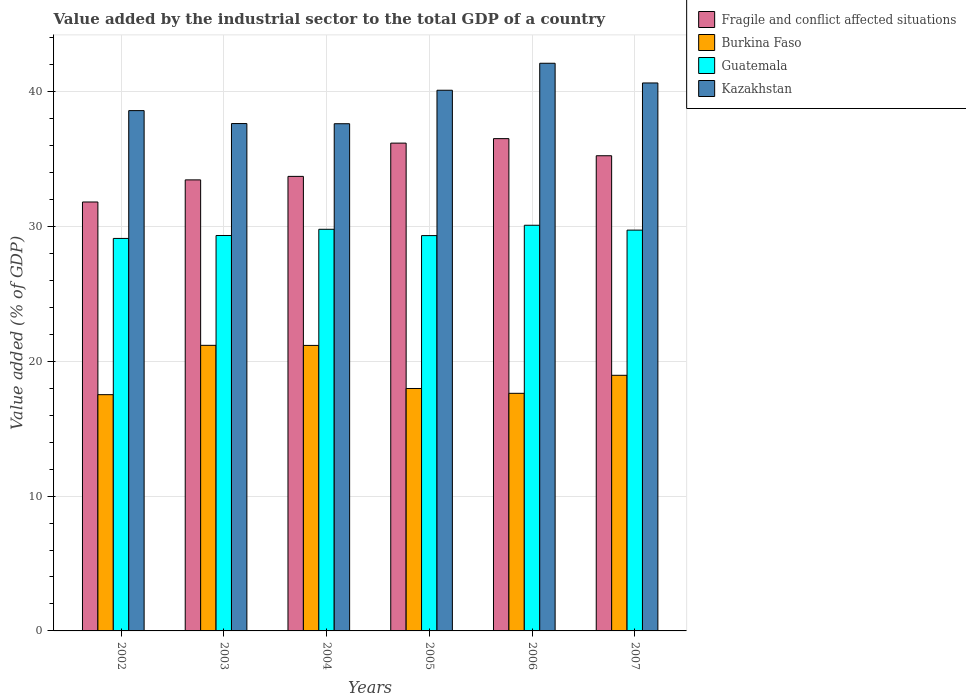How many different coloured bars are there?
Offer a terse response. 4. Are the number of bars per tick equal to the number of legend labels?
Your answer should be compact. Yes. Are the number of bars on each tick of the X-axis equal?
Provide a succinct answer. Yes. How many bars are there on the 6th tick from the right?
Provide a short and direct response. 4. What is the label of the 6th group of bars from the left?
Your answer should be very brief. 2007. In how many cases, is the number of bars for a given year not equal to the number of legend labels?
Ensure brevity in your answer.  0. What is the value added by the industrial sector to the total GDP in Kazakhstan in 2007?
Your answer should be very brief. 40.64. Across all years, what is the maximum value added by the industrial sector to the total GDP in Guatemala?
Keep it short and to the point. 30.09. Across all years, what is the minimum value added by the industrial sector to the total GDP in Kazakhstan?
Give a very brief answer. 37.62. In which year was the value added by the industrial sector to the total GDP in Fragile and conflict affected situations maximum?
Offer a very short reply. 2006. In which year was the value added by the industrial sector to the total GDP in Fragile and conflict affected situations minimum?
Ensure brevity in your answer.  2002. What is the total value added by the industrial sector to the total GDP in Fragile and conflict affected situations in the graph?
Ensure brevity in your answer.  206.91. What is the difference between the value added by the industrial sector to the total GDP in Burkina Faso in 2005 and that in 2006?
Offer a very short reply. 0.36. What is the difference between the value added by the industrial sector to the total GDP in Guatemala in 2007 and the value added by the industrial sector to the total GDP in Burkina Faso in 2002?
Provide a short and direct response. 12.2. What is the average value added by the industrial sector to the total GDP in Burkina Faso per year?
Keep it short and to the point. 19.07. In the year 2004, what is the difference between the value added by the industrial sector to the total GDP in Fragile and conflict affected situations and value added by the industrial sector to the total GDP in Kazakhstan?
Your response must be concise. -3.9. In how many years, is the value added by the industrial sector to the total GDP in Fragile and conflict affected situations greater than 22 %?
Keep it short and to the point. 6. What is the ratio of the value added by the industrial sector to the total GDP in Fragile and conflict affected situations in 2004 to that in 2006?
Your response must be concise. 0.92. Is the value added by the industrial sector to the total GDP in Kazakhstan in 2002 less than that in 2005?
Your answer should be very brief. Yes. What is the difference between the highest and the second highest value added by the industrial sector to the total GDP in Kazakhstan?
Provide a succinct answer. 1.46. What is the difference between the highest and the lowest value added by the industrial sector to the total GDP in Guatemala?
Your response must be concise. 0.98. Is it the case that in every year, the sum of the value added by the industrial sector to the total GDP in Guatemala and value added by the industrial sector to the total GDP in Kazakhstan is greater than the sum of value added by the industrial sector to the total GDP in Fragile and conflict affected situations and value added by the industrial sector to the total GDP in Burkina Faso?
Keep it short and to the point. No. What does the 1st bar from the left in 2006 represents?
Provide a short and direct response. Fragile and conflict affected situations. What does the 3rd bar from the right in 2004 represents?
Offer a terse response. Burkina Faso. Is it the case that in every year, the sum of the value added by the industrial sector to the total GDP in Burkina Faso and value added by the industrial sector to the total GDP in Kazakhstan is greater than the value added by the industrial sector to the total GDP in Guatemala?
Provide a short and direct response. Yes. Are all the bars in the graph horizontal?
Your answer should be compact. No. How many years are there in the graph?
Your answer should be compact. 6. Are the values on the major ticks of Y-axis written in scientific E-notation?
Your answer should be very brief. No. Does the graph contain grids?
Your response must be concise. Yes. How many legend labels are there?
Your answer should be very brief. 4. What is the title of the graph?
Offer a very short reply. Value added by the industrial sector to the total GDP of a country. What is the label or title of the Y-axis?
Keep it short and to the point. Value added (% of GDP). What is the Value added (% of GDP) in Fragile and conflict affected situations in 2002?
Your answer should be very brief. 31.81. What is the Value added (% of GDP) in Burkina Faso in 2002?
Give a very brief answer. 17.52. What is the Value added (% of GDP) of Guatemala in 2002?
Keep it short and to the point. 29.11. What is the Value added (% of GDP) in Kazakhstan in 2002?
Offer a very short reply. 38.59. What is the Value added (% of GDP) in Fragile and conflict affected situations in 2003?
Provide a short and direct response. 33.45. What is the Value added (% of GDP) in Burkina Faso in 2003?
Provide a succinct answer. 21.18. What is the Value added (% of GDP) of Guatemala in 2003?
Provide a short and direct response. 29.33. What is the Value added (% of GDP) in Kazakhstan in 2003?
Offer a terse response. 37.63. What is the Value added (% of GDP) in Fragile and conflict affected situations in 2004?
Keep it short and to the point. 33.71. What is the Value added (% of GDP) in Burkina Faso in 2004?
Your answer should be very brief. 21.18. What is the Value added (% of GDP) in Guatemala in 2004?
Your answer should be very brief. 29.79. What is the Value added (% of GDP) in Kazakhstan in 2004?
Give a very brief answer. 37.62. What is the Value added (% of GDP) in Fragile and conflict affected situations in 2005?
Ensure brevity in your answer.  36.18. What is the Value added (% of GDP) in Burkina Faso in 2005?
Give a very brief answer. 17.98. What is the Value added (% of GDP) in Guatemala in 2005?
Your answer should be very brief. 29.32. What is the Value added (% of GDP) of Kazakhstan in 2005?
Ensure brevity in your answer.  40.1. What is the Value added (% of GDP) of Fragile and conflict affected situations in 2006?
Your response must be concise. 36.51. What is the Value added (% of GDP) in Burkina Faso in 2006?
Offer a very short reply. 17.62. What is the Value added (% of GDP) of Guatemala in 2006?
Your answer should be very brief. 30.09. What is the Value added (% of GDP) of Kazakhstan in 2006?
Provide a succinct answer. 42.1. What is the Value added (% of GDP) of Fragile and conflict affected situations in 2007?
Keep it short and to the point. 35.24. What is the Value added (% of GDP) in Burkina Faso in 2007?
Keep it short and to the point. 18.96. What is the Value added (% of GDP) of Guatemala in 2007?
Provide a short and direct response. 29.73. What is the Value added (% of GDP) in Kazakhstan in 2007?
Ensure brevity in your answer.  40.64. Across all years, what is the maximum Value added (% of GDP) in Fragile and conflict affected situations?
Your answer should be compact. 36.51. Across all years, what is the maximum Value added (% of GDP) in Burkina Faso?
Keep it short and to the point. 21.18. Across all years, what is the maximum Value added (% of GDP) in Guatemala?
Make the answer very short. 30.09. Across all years, what is the maximum Value added (% of GDP) of Kazakhstan?
Offer a terse response. 42.1. Across all years, what is the minimum Value added (% of GDP) of Fragile and conflict affected situations?
Offer a very short reply. 31.81. Across all years, what is the minimum Value added (% of GDP) of Burkina Faso?
Make the answer very short. 17.52. Across all years, what is the minimum Value added (% of GDP) in Guatemala?
Offer a very short reply. 29.11. Across all years, what is the minimum Value added (% of GDP) in Kazakhstan?
Your answer should be very brief. 37.62. What is the total Value added (% of GDP) of Fragile and conflict affected situations in the graph?
Keep it short and to the point. 206.91. What is the total Value added (% of GDP) in Burkina Faso in the graph?
Give a very brief answer. 114.44. What is the total Value added (% of GDP) of Guatemala in the graph?
Offer a terse response. 177.36. What is the total Value added (% of GDP) of Kazakhstan in the graph?
Offer a very short reply. 236.67. What is the difference between the Value added (% of GDP) of Fragile and conflict affected situations in 2002 and that in 2003?
Keep it short and to the point. -1.64. What is the difference between the Value added (% of GDP) in Burkina Faso in 2002 and that in 2003?
Provide a succinct answer. -3.66. What is the difference between the Value added (% of GDP) of Guatemala in 2002 and that in 2003?
Your answer should be compact. -0.22. What is the difference between the Value added (% of GDP) of Kazakhstan in 2002 and that in 2003?
Your answer should be compact. 0.96. What is the difference between the Value added (% of GDP) in Fragile and conflict affected situations in 2002 and that in 2004?
Offer a terse response. -1.9. What is the difference between the Value added (% of GDP) of Burkina Faso in 2002 and that in 2004?
Make the answer very short. -3.65. What is the difference between the Value added (% of GDP) of Guatemala in 2002 and that in 2004?
Provide a short and direct response. -0.68. What is the difference between the Value added (% of GDP) in Kazakhstan in 2002 and that in 2004?
Offer a very short reply. 0.97. What is the difference between the Value added (% of GDP) of Fragile and conflict affected situations in 2002 and that in 2005?
Keep it short and to the point. -4.37. What is the difference between the Value added (% of GDP) in Burkina Faso in 2002 and that in 2005?
Make the answer very short. -0.46. What is the difference between the Value added (% of GDP) of Guatemala in 2002 and that in 2005?
Offer a very short reply. -0.21. What is the difference between the Value added (% of GDP) of Kazakhstan in 2002 and that in 2005?
Give a very brief answer. -1.51. What is the difference between the Value added (% of GDP) in Fragile and conflict affected situations in 2002 and that in 2006?
Keep it short and to the point. -4.7. What is the difference between the Value added (% of GDP) in Burkina Faso in 2002 and that in 2006?
Provide a succinct answer. -0.1. What is the difference between the Value added (% of GDP) in Guatemala in 2002 and that in 2006?
Keep it short and to the point. -0.98. What is the difference between the Value added (% of GDP) in Kazakhstan in 2002 and that in 2006?
Make the answer very short. -3.51. What is the difference between the Value added (% of GDP) in Fragile and conflict affected situations in 2002 and that in 2007?
Keep it short and to the point. -3.43. What is the difference between the Value added (% of GDP) in Burkina Faso in 2002 and that in 2007?
Make the answer very short. -1.44. What is the difference between the Value added (% of GDP) of Guatemala in 2002 and that in 2007?
Your answer should be compact. -0.62. What is the difference between the Value added (% of GDP) in Kazakhstan in 2002 and that in 2007?
Keep it short and to the point. -2.05. What is the difference between the Value added (% of GDP) in Fragile and conflict affected situations in 2003 and that in 2004?
Provide a succinct answer. -0.26. What is the difference between the Value added (% of GDP) in Burkina Faso in 2003 and that in 2004?
Provide a short and direct response. 0.01. What is the difference between the Value added (% of GDP) of Guatemala in 2003 and that in 2004?
Your answer should be compact. -0.46. What is the difference between the Value added (% of GDP) of Kazakhstan in 2003 and that in 2004?
Keep it short and to the point. 0.01. What is the difference between the Value added (% of GDP) in Fragile and conflict affected situations in 2003 and that in 2005?
Your response must be concise. -2.73. What is the difference between the Value added (% of GDP) of Burkina Faso in 2003 and that in 2005?
Provide a short and direct response. 3.2. What is the difference between the Value added (% of GDP) of Guatemala in 2003 and that in 2005?
Give a very brief answer. 0.01. What is the difference between the Value added (% of GDP) in Kazakhstan in 2003 and that in 2005?
Your response must be concise. -2.47. What is the difference between the Value added (% of GDP) of Fragile and conflict affected situations in 2003 and that in 2006?
Provide a short and direct response. -3.06. What is the difference between the Value added (% of GDP) in Burkina Faso in 2003 and that in 2006?
Your response must be concise. 3.56. What is the difference between the Value added (% of GDP) in Guatemala in 2003 and that in 2006?
Offer a terse response. -0.76. What is the difference between the Value added (% of GDP) in Kazakhstan in 2003 and that in 2006?
Make the answer very short. -4.47. What is the difference between the Value added (% of GDP) of Fragile and conflict affected situations in 2003 and that in 2007?
Give a very brief answer. -1.79. What is the difference between the Value added (% of GDP) in Burkina Faso in 2003 and that in 2007?
Ensure brevity in your answer.  2.22. What is the difference between the Value added (% of GDP) of Guatemala in 2003 and that in 2007?
Your answer should be compact. -0.4. What is the difference between the Value added (% of GDP) in Kazakhstan in 2003 and that in 2007?
Provide a succinct answer. -3.01. What is the difference between the Value added (% of GDP) in Fragile and conflict affected situations in 2004 and that in 2005?
Provide a succinct answer. -2.47. What is the difference between the Value added (% of GDP) of Burkina Faso in 2004 and that in 2005?
Make the answer very short. 3.2. What is the difference between the Value added (% of GDP) of Guatemala in 2004 and that in 2005?
Give a very brief answer. 0.47. What is the difference between the Value added (% of GDP) of Kazakhstan in 2004 and that in 2005?
Your response must be concise. -2.48. What is the difference between the Value added (% of GDP) in Fragile and conflict affected situations in 2004 and that in 2006?
Your response must be concise. -2.8. What is the difference between the Value added (% of GDP) in Burkina Faso in 2004 and that in 2006?
Ensure brevity in your answer.  3.55. What is the difference between the Value added (% of GDP) in Guatemala in 2004 and that in 2006?
Your response must be concise. -0.3. What is the difference between the Value added (% of GDP) in Kazakhstan in 2004 and that in 2006?
Your answer should be compact. -4.49. What is the difference between the Value added (% of GDP) in Fragile and conflict affected situations in 2004 and that in 2007?
Offer a very short reply. -1.53. What is the difference between the Value added (% of GDP) in Burkina Faso in 2004 and that in 2007?
Provide a short and direct response. 2.22. What is the difference between the Value added (% of GDP) in Guatemala in 2004 and that in 2007?
Give a very brief answer. 0.06. What is the difference between the Value added (% of GDP) of Kazakhstan in 2004 and that in 2007?
Give a very brief answer. -3.02. What is the difference between the Value added (% of GDP) of Fragile and conflict affected situations in 2005 and that in 2006?
Offer a very short reply. -0.33. What is the difference between the Value added (% of GDP) of Burkina Faso in 2005 and that in 2006?
Your answer should be very brief. 0.36. What is the difference between the Value added (% of GDP) in Guatemala in 2005 and that in 2006?
Your response must be concise. -0.77. What is the difference between the Value added (% of GDP) of Kazakhstan in 2005 and that in 2006?
Your response must be concise. -2. What is the difference between the Value added (% of GDP) of Fragile and conflict affected situations in 2005 and that in 2007?
Offer a very short reply. 0.94. What is the difference between the Value added (% of GDP) of Burkina Faso in 2005 and that in 2007?
Your answer should be compact. -0.98. What is the difference between the Value added (% of GDP) of Guatemala in 2005 and that in 2007?
Provide a short and direct response. -0.41. What is the difference between the Value added (% of GDP) of Kazakhstan in 2005 and that in 2007?
Provide a short and direct response. -0.54. What is the difference between the Value added (% of GDP) of Fragile and conflict affected situations in 2006 and that in 2007?
Your response must be concise. 1.27. What is the difference between the Value added (% of GDP) in Burkina Faso in 2006 and that in 2007?
Ensure brevity in your answer.  -1.34. What is the difference between the Value added (% of GDP) of Guatemala in 2006 and that in 2007?
Give a very brief answer. 0.36. What is the difference between the Value added (% of GDP) in Kazakhstan in 2006 and that in 2007?
Ensure brevity in your answer.  1.46. What is the difference between the Value added (% of GDP) in Fragile and conflict affected situations in 2002 and the Value added (% of GDP) in Burkina Faso in 2003?
Make the answer very short. 10.63. What is the difference between the Value added (% of GDP) in Fragile and conflict affected situations in 2002 and the Value added (% of GDP) in Guatemala in 2003?
Make the answer very short. 2.48. What is the difference between the Value added (% of GDP) of Fragile and conflict affected situations in 2002 and the Value added (% of GDP) of Kazakhstan in 2003?
Make the answer very short. -5.82. What is the difference between the Value added (% of GDP) of Burkina Faso in 2002 and the Value added (% of GDP) of Guatemala in 2003?
Make the answer very short. -11.8. What is the difference between the Value added (% of GDP) in Burkina Faso in 2002 and the Value added (% of GDP) in Kazakhstan in 2003?
Provide a succinct answer. -20.11. What is the difference between the Value added (% of GDP) in Guatemala in 2002 and the Value added (% of GDP) in Kazakhstan in 2003?
Your answer should be compact. -8.52. What is the difference between the Value added (% of GDP) of Fragile and conflict affected situations in 2002 and the Value added (% of GDP) of Burkina Faso in 2004?
Offer a terse response. 10.64. What is the difference between the Value added (% of GDP) in Fragile and conflict affected situations in 2002 and the Value added (% of GDP) in Guatemala in 2004?
Offer a terse response. 2.02. What is the difference between the Value added (% of GDP) in Fragile and conflict affected situations in 2002 and the Value added (% of GDP) in Kazakhstan in 2004?
Your response must be concise. -5.8. What is the difference between the Value added (% of GDP) of Burkina Faso in 2002 and the Value added (% of GDP) of Guatemala in 2004?
Offer a terse response. -12.27. What is the difference between the Value added (% of GDP) in Burkina Faso in 2002 and the Value added (% of GDP) in Kazakhstan in 2004?
Ensure brevity in your answer.  -20.09. What is the difference between the Value added (% of GDP) in Guatemala in 2002 and the Value added (% of GDP) in Kazakhstan in 2004?
Offer a very short reply. -8.51. What is the difference between the Value added (% of GDP) in Fragile and conflict affected situations in 2002 and the Value added (% of GDP) in Burkina Faso in 2005?
Provide a short and direct response. 13.83. What is the difference between the Value added (% of GDP) in Fragile and conflict affected situations in 2002 and the Value added (% of GDP) in Guatemala in 2005?
Your answer should be compact. 2.49. What is the difference between the Value added (% of GDP) of Fragile and conflict affected situations in 2002 and the Value added (% of GDP) of Kazakhstan in 2005?
Ensure brevity in your answer.  -8.29. What is the difference between the Value added (% of GDP) in Burkina Faso in 2002 and the Value added (% of GDP) in Guatemala in 2005?
Your answer should be compact. -11.8. What is the difference between the Value added (% of GDP) in Burkina Faso in 2002 and the Value added (% of GDP) in Kazakhstan in 2005?
Your answer should be compact. -22.58. What is the difference between the Value added (% of GDP) in Guatemala in 2002 and the Value added (% of GDP) in Kazakhstan in 2005?
Your response must be concise. -10.99. What is the difference between the Value added (% of GDP) of Fragile and conflict affected situations in 2002 and the Value added (% of GDP) of Burkina Faso in 2006?
Provide a short and direct response. 14.19. What is the difference between the Value added (% of GDP) of Fragile and conflict affected situations in 2002 and the Value added (% of GDP) of Guatemala in 2006?
Provide a short and direct response. 1.72. What is the difference between the Value added (% of GDP) in Fragile and conflict affected situations in 2002 and the Value added (% of GDP) in Kazakhstan in 2006?
Your answer should be compact. -10.29. What is the difference between the Value added (% of GDP) of Burkina Faso in 2002 and the Value added (% of GDP) of Guatemala in 2006?
Provide a short and direct response. -12.56. What is the difference between the Value added (% of GDP) in Burkina Faso in 2002 and the Value added (% of GDP) in Kazakhstan in 2006?
Your answer should be very brief. -24.58. What is the difference between the Value added (% of GDP) in Guatemala in 2002 and the Value added (% of GDP) in Kazakhstan in 2006?
Keep it short and to the point. -12.99. What is the difference between the Value added (% of GDP) in Fragile and conflict affected situations in 2002 and the Value added (% of GDP) in Burkina Faso in 2007?
Make the answer very short. 12.85. What is the difference between the Value added (% of GDP) in Fragile and conflict affected situations in 2002 and the Value added (% of GDP) in Guatemala in 2007?
Offer a terse response. 2.09. What is the difference between the Value added (% of GDP) of Fragile and conflict affected situations in 2002 and the Value added (% of GDP) of Kazakhstan in 2007?
Offer a terse response. -8.83. What is the difference between the Value added (% of GDP) of Burkina Faso in 2002 and the Value added (% of GDP) of Guatemala in 2007?
Offer a very short reply. -12.2. What is the difference between the Value added (% of GDP) in Burkina Faso in 2002 and the Value added (% of GDP) in Kazakhstan in 2007?
Make the answer very short. -23.12. What is the difference between the Value added (% of GDP) of Guatemala in 2002 and the Value added (% of GDP) of Kazakhstan in 2007?
Give a very brief answer. -11.53. What is the difference between the Value added (% of GDP) in Fragile and conflict affected situations in 2003 and the Value added (% of GDP) in Burkina Faso in 2004?
Your answer should be compact. 12.28. What is the difference between the Value added (% of GDP) of Fragile and conflict affected situations in 2003 and the Value added (% of GDP) of Guatemala in 2004?
Keep it short and to the point. 3.66. What is the difference between the Value added (% of GDP) in Fragile and conflict affected situations in 2003 and the Value added (% of GDP) in Kazakhstan in 2004?
Your response must be concise. -4.16. What is the difference between the Value added (% of GDP) in Burkina Faso in 2003 and the Value added (% of GDP) in Guatemala in 2004?
Provide a short and direct response. -8.61. What is the difference between the Value added (% of GDP) in Burkina Faso in 2003 and the Value added (% of GDP) in Kazakhstan in 2004?
Make the answer very short. -16.44. What is the difference between the Value added (% of GDP) in Guatemala in 2003 and the Value added (% of GDP) in Kazakhstan in 2004?
Make the answer very short. -8.29. What is the difference between the Value added (% of GDP) of Fragile and conflict affected situations in 2003 and the Value added (% of GDP) of Burkina Faso in 2005?
Your answer should be very brief. 15.47. What is the difference between the Value added (% of GDP) in Fragile and conflict affected situations in 2003 and the Value added (% of GDP) in Guatemala in 2005?
Provide a succinct answer. 4.13. What is the difference between the Value added (% of GDP) in Fragile and conflict affected situations in 2003 and the Value added (% of GDP) in Kazakhstan in 2005?
Offer a very short reply. -6.65. What is the difference between the Value added (% of GDP) of Burkina Faso in 2003 and the Value added (% of GDP) of Guatemala in 2005?
Provide a succinct answer. -8.14. What is the difference between the Value added (% of GDP) in Burkina Faso in 2003 and the Value added (% of GDP) in Kazakhstan in 2005?
Offer a very short reply. -18.92. What is the difference between the Value added (% of GDP) in Guatemala in 2003 and the Value added (% of GDP) in Kazakhstan in 2005?
Offer a very short reply. -10.77. What is the difference between the Value added (% of GDP) of Fragile and conflict affected situations in 2003 and the Value added (% of GDP) of Burkina Faso in 2006?
Provide a short and direct response. 15.83. What is the difference between the Value added (% of GDP) of Fragile and conflict affected situations in 2003 and the Value added (% of GDP) of Guatemala in 2006?
Your answer should be compact. 3.37. What is the difference between the Value added (% of GDP) in Fragile and conflict affected situations in 2003 and the Value added (% of GDP) in Kazakhstan in 2006?
Offer a terse response. -8.65. What is the difference between the Value added (% of GDP) of Burkina Faso in 2003 and the Value added (% of GDP) of Guatemala in 2006?
Keep it short and to the point. -8.91. What is the difference between the Value added (% of GDP) of Burkina Faso in 2003 and the Value added (% of GDP) of Kazakhstan in 2006?
Ensure brevity in your answer.  -20.92. What is the difference between the Value added (% of GDP) in Guatemala in 2003 and the Value added (% of GDP) in Kazakhstan in 2006?
Provide a short and direct response. -12.77. What is the difference between the Value added (% of GDP) in Fragile and conflict affected situations in 2003 and the Value added (% of GDP) in Burkina Faso in 2007?
Offer a very short reply. 14.49. What is the difference between the Value added (% of GDP) of Fragile and conflict affected situations in 2003 and the Value added (% of GDP) of Guatemala in 2007?
Keep it short and to the point. 3.73. What is the difference between the Value added (% of GDP) in Fragile and conflict affected situations in 2003 and the Value added (% of GDP) in Kazakhstan in 2007?
Provide a succinct answer. -7.19. What is the difference between the Value added (% of GDP) of Burkina Faso in 2003 and the Value added (% of GDP) of Guatemala in 2007?
Offer a terse response. -8.54. What is the difference between the Value added (% of GDP) of Burkina Faso in 2003 and the Value added (% of GDP) of Kazakhstan in 2007?
Keep it short and to the point. -19.46. What is the difference between the Value added (% of GDP) in Guatemala in 2003 and the Value added (% of GDP) in Kazakhstan in 2007?
Your response must be concise. -11.31. What is the difference between the Value added (% of GDP) in Fragile and conflict affected situations in 2004 and the Value added (% of GDP) in Burkina Faso in 2005?
Ensure brevity in your answer.  15.73. What is the difference between the Value added (% of GDP) in Fragile and conflict affected situations in 2004 and the Value added (% of GDP) in Guatemala in 2005?
Provide a succinct answer. 4.39. What is the difference between the Value added (% of GDP) in Fragile and conflict affected situations in 2004 and the Value added (% of GDP) in Kazakhstan in 2005?
Provide a succinct answer. -6.39. What is the difference between the Value added (% of GDP) in Burkina Faso in 2004 and the Value added (% of GDP) in Guatemala in 2005?
Give a very brief answer. -8.14. What is the difference between the Value added (% of GDP) in Burkina Faso in 2004 and the Value added (% of GDP) in Kazakhstan in 2005?
Your answer should be very brief. -18.92. What is the difference between the Value added (% of GDP) in Guatemala in 2004 and the Value added (% of GDP) in Kazakhstan in 2005?
Provide a short and direct response. -10.31. What is the difference between the Value added (% of GDP) of Fragile and conflict affected situations in 2004 and the Value added (% of GDP) of Burkina Faso in 2006?
Offer a very short reply. 16.09. What is the difference between the Value added (% of GDP) of Fragile and conflict affected situations in 2004 and the Value added (% of GDP) of Guatemala in 2006?
Your answer should be very brief. 3.62. What is the difference between the Value added (% of GDP) of Fragile and conflict affected situations in 2004 and the Value added (% of GDP) of Kazakhstan in 2006?
Offer a terse response. -8.39. What is the difference between the Value added (% of GDP) of Burkina Faso in 2004 and the Value added (% of GDP) of Guatemala in 2006?
Your answer should be very brief. -8.91. What is the difference between the Value added (% of GDP) in Burkina Faso in 2004 and the Value added (% of GDP) in Kazakhstan in 2006?
Your answer should be compact. -20.93. What is the difference between the Value added (% of GDP) in Guatemala in 2004 and the Value added (% of GDP) in Kazakhstan in 2006?
Make the answer very short. -12.31. What is the difference between the Value added (% of GDP) of Fragile and conflict affected situations in 2004 and the Value added (% of GDP) of Burkina Faso in 2007?
Your answer should be very brief. 14.75. What is the difference between the Value added (% of GDP) of Fragile and conflict affected situations in 2004 and the Value added (% of GDP) of Guatemala in 2007?
Provide a short and direct response. 3.99. What is the difference between the Value added (% of GDP) in Fragile and conflict affected situations in 2004 and the Value added (% of GDP) in Kazakhstan in 2007?
Make the answer very short. -6.93. What is the difference between the Value added (% of GDP) of Burkina Faso in 2004 and the Value added (% of GDP) of Guatemala in 2007?
Ensure brevity in your answer.  -8.55. What is the difference between the Value added (% of GDP) in Burkina Faso in 2004 and the Value added (% of GDP) in Kazakhstan in 2007?
Provide a short and direct response. -19.46. What is the difference between the Value added (% of GDP) in Guatemala in 2004 and the Value added (% of GDP) in Kazakhstan in 2007?
Ensure brevity in your answer.  -10.85. What is the difference between the Value added (% of GDP) in Fragile and conflict affected situations in 2005 and the Value added (% of GDP) in Burkina Faso in 2006?
Offer a terse response. 18.56. What is the difference between the Value added (% of GDP) in Fragile and conflict affected situations in 2005 and the Value added (% of GDP) in Guatemala in 2006?
Offer a very short reply. 6.09. What is the difference between the Value added (% of GDP) of Fragile and conflict affected situations in 2005 and the Value added (% of GDP) of Kazakhstan in 2006?
Offer a terse response. -5.92. What is the difference between the Value added (% of GDP) of Burkina Faso in 2005 and the Value added (% of GDP) of Guatemala in 2006?
Offer a terse response. -12.11. What is the difference between the Value added (% of GDP) in Burkina Faso in 2005 and the Value added (% of GDP) in Kazakhstan in 2006?
Make the answer very short. -24.12. What is the difference between the Value added (% of GDP) in Guatemala in 2005 and the Value added (% of GDP) in Kazakhstan in 2006?
Provide a short and direct response. -12.78. What is the difference between the Value added (% of GDP) of Fragile and conflict affected situations in 2005 and the Value added (% of GDP) of Burkina Faso in 2007?
Your answer should be very brief. 17.22. What is the difference between the Value added (% of GDP) in Fragile and conflict affected situations in 2005 and the Value added (% of GDP) in Guatemala in 2007?
Offer a terse response. 6.45. What is the difference between the Value added (% of GDP) in Fragile and conflict affected situations in 2005 and the Value added (% of GDP) in Kazakhstan in 2007?
Provide a short and direct response. -4.46. What is the difference between the Value added (% of GDP) in Burkina Faso in 2005 and the Value added (% of GDP) in Guatemala in 2007?
Keep it short and to the point. -11.75. What is the difference between the Value added (% of GDP) in Burkina Faso in 2005 and the Value added (% of GDP) in Kazakhstan in 2007?
Provide a succinct answer. -22.66. What is the difference between the Value added (% of GDP) in Guatemala in 2005 and the Value added (% of GDP) in Kazakhstan in 2007?
Your answer should be very brief. -11.32. What is the difference between the Value added (% of GDP) of Fragile and conflict affected situations in 2006 and the Value added (% of GDP) of Burkina Faso in 2007?
Your response must be concise. 17.55. What is the difference between the Value added (% of GDP) of Fragile and conflict affected situations in 2006 and the Value added (% of GDP) of Guatemala in 2007?
Provide a short and direct response. 6.78. What is the difference between the Value added (% of GDP) of Fragile and conflict affected situations in 2006 and the Value added (% of GDP) of Kazakhstan in 2007?
Give a very brief answer. -4.13. What is the difference between the Value added (% of GDP) of Burkina Faso in 2006 and the Value added (% of GDP) of Guatemala in 2007?
Offer a very short reply. -12.1. What is the difference between the Value added (% of GDP) in Burkina Faso in 2006 and the Value added (% of GDP) in Kazakhstan in 2007?
Make the answer very short. -23.02. What is the difference between the Value added (% of GDP) in Guatemala in 2006 and the Value added (% of GDP) in Kazakhstan in 2007?
Make the answer very short. -10.55. What is the average Value added (% of GDP) of Fragile and conflict affected situations per year?
Give a very brief answer. 34.48. What is the average Value added (% of GDP) in Burkina Faso per year?
Make the answer very short. 19.07. What is the average Value added (% of GDP) in Guatemala per year?
Make the answer very short. 29.56. What is the average Value added (% of GDP) in Kazakhstan per year?
Offer a terse response. 39.45. In the year 2002, what is the difference between the Value added (% of GDP) of Fragile and conflict affected situations and Value added (% of GDP) of Burkina Faso?
Your answer should be very brief. 14.29. In the year 2002, what is the difference between the Value added (% of GDP) of Fragile and conflict affected situations and Value added (% of GDP) of Guatemala?
Keep it short and to the point. 2.7. In the year 2002, what is the difference between the Value added (% of GDP) in Fragile and conflict affected situations and Value added (% of GDP) in Kazakhstan?
Give a very brief answer. -6.78. In the year 2002, what is the difference between the Value added (% of GDP) in Burkina Faso and Value added (% of GDP) in Guatemala?
Provide a short and direct response. -11.59. In the year 2002, what is the difference between the Value added (% of GDP) of Burkina Faso and Value added (% of GDP) of Kazakhstan?
Make the answer very short. -21.07. In the year 2002, what is the difference between the Value added (% of GDP) in Guatemala and Value added (% of GDP) in Kazakhstan?
Provide a short and direct response. -9.48. In the year 2003, what is the difference between the Value added (% of GDP) of Fragile and conflict affected situations and Value added (% of GDP) of Burkina Faso?
Ensure brevity in your answer.  12.27. In the year 2003, what is the difference between the Value added (% of GDP) of Fragile and conflict affected situations and Value added (% of GDP) of Guatemala?
Your answer should be compact. 4.13. In the year 2003, what is the difference between the Value added (% of GDP) in Fragile and conflict affected situations and Value added (% of GDP) in Kazakhstan?
Offer a terse response. -4.18. In the year 2003, what is the difference between the Value added (% of GDP) in Burkina Faso and Value added (% of GDP) in Guatemala?
Your answer should be compact. -8.15. In the year 2003, what is the difference between the Value added (% of GDP) in Burkina Faso and Value added (% of GDP) in Kazakhstan?
Your response must be concise. -16.45. In the year 2003, what is the difference between the Value added (% of GDP) in Guatemala and Value added (% of GDP) in Kazakhstan?
Your response must be concise. -8.3. In the year 2004, what is the difference between the Value added (% of GDP) in Fragile and conflict affected situations and Value added (% of GDP) in Burkina Faso?
Give a very brief answer. 12.54. In the year 2004, what is the difference between the Value added (% of GDP) in Fragile and conflict affected situations and Value added (% of GDP) in Guatemala?
Provide a succinct answer. 3.92. In the year 2004, what is the difference between the Value added (% of GDP) of Fragile and conflict affected situations and Value added (% of GDP) of Kazakhstan?
Your answer should be compact. -3.9. In the year 2004, what is the difference between the Value added (% of GDP) in Burkina Faso and Value added (% of GDP) in Guatemala?
Your answer should be very brief. -8.61. In the year 2004, what is the difference between the Value added (% of GDP) in Burkina Faso and Value added (% of GDP) in Kazakhstan?
Provide a short and direct response. -16.44. In the year 2004, what is the difference between the Value added (% of GDP) in Guatemala and Value added (% of GDP) in Kazakhstan?
Your answer should be very brief. -7.83. In the year 2005, what is the difference between the Value added (% of GDP) in Fragile and conflict affected situations and Value added (% of GDP) in Burkina Faso?
Your answer should be compact. 18.2. In the year 2005, what is the difference between the Value added (% of GDP) of Fragile and conflict affected situations and Value added (% of GDP) of Guatemala?
Make the answer very short. 6.86. In the year 2005, what is the difference between the Value added (% of GDP) of Fragile and conflict affected situations and Value added (% of GDP) of Kazakhstan?
Provide a short and direct response. -3.92. In the year 2005, what is the difference between the Value added (% of GDP) in Burkina Faso and Value added (% of GDP) in Guatemala?
Ensure brevity in your answer.  -11.34. In the year 2005, what is the difference between the Value added (% of GDP) in Burkina Faso and Value added (% of GDP) in Kazakhstan?
Your answer should be very brief. -22.12. In the year 2005, what is the difference between the Value added (% of GDP) in Guatemala and Value added (% of GDP) in Kazakhstan?
Ensure brevity in your answer.  -10.78. In the year 2006, what is the difference between the Value added (% of GDP) of Fragile and conflict affected situations and Value added (% of GDP) of Burkina Faso?
Make the answer very short. 18.89. In the year 2006, what is the difference between the Value added (% of GDP) in Fragile and conflict affected situations and Value added (% of GDP) in Guatemala?
Ensure brevity in your answer.  6.42. In the year 2006, what is the difference between the Value added (% of GDP) of Fragile and conflict affected situations and Value added (% of GDP) of Kazakhstan?
Your answer should be very brief. -5.59. In the year 2006, what is the difference between the Value added (% of GDP) of Burkina Faso and Value added (% of GDP) of Guatemala?
Give a very brief answer. -12.46. In the year 2006, what is the difference between the Value added (% of GDP) of Burkina Faso and Value added (% of GDP) of Kazakhstan?
Your answer should be very brief. -24.48. In the year 2006, what is the difference between the Value added (% of GDP) of Guatemala and Value added (% of GDP) of Kazakhstan?
Keep it short and to the point. -12.01. In the year 2007, what is the difference between the Value added (% of GDP) of Fragile and conflict affected situations and Value added (% of GDP) of Burkina Faso?
Give a very brief answer. 16.29. In the year 2007, what is the difference between the Value added (% of GDP) in Fragile and conflict affected situations and Value added (% of GDP) in Guatemala?
Your answer should be very brief. 5.52. In the year 2007, what is the difference between the Value added (% of GDP) in Fragile and conflict affected situations and Value added (% of GDP) in Kazakhstan?
Your answer should be very brief. -5.4. In the year 2007, what is the difference between the Value added (% of GDP) in Burkina Faso and Value added (% of GDP) in Guatemala?
Your answer should be very brief. -10.77. In the year 2007, what is the difference between the Value added (% of GDP) of Burkina Faso and Value added (% of GDP) of Kazakhstan?
Provide a short and direct response. -21.68. In the year 2007, what is the difference between the Value added (% of GDP) of Guatemala and Value added (% of GDP) of Kazakhstan?
Give a very brief answer. -10.91. What is the ratio of the Value added (% of GDP) of Fragile and conflict affected situations in 2002 to that in 2003?
Keep it short and to the point. 0.95. What is the ratio of the Value added (% of GDP) of Burkina Faso in 2002 to that in 2003?
Make the answer very short. 0.83. What is the ratio of the Value added (% of GDP) of Kazakhstan in 2002 to that in 2003?
Your response must be concise. 1.03. What is the ratio of the Value added (% of GDP) of Fragile and conflict affected situations in 2002 to that in 2004?
Your answer should be compact. 0.94. What is the ratio of the Value added (% of GDP) in Burkina Faso in 2002 to that in 2004?
Keep it short and to the point. 0.83. What is the ratio of the Value added (% of GDP) in Guatemala in 2002 to that in 2004?
Provide a succinct answer. 0.98. What is the ratio of the Value added (% of GDP) in Kazakhstan in 2002 to that in 2004?
Your response must be concise. 1.03. What is the ratio of the Value added (% of GDP) in Fragile and conflict affected situations in 2002 to that in 2005?
Provide a succinct answer. 0.88. What is the ratio of the Value added (% of GDP) of Burkina Faso in 2002 to that in 2005?
Provide a short and direct response. 0.97. What is the ratio of the Value added (% of GDP) in Guatemala in 2002 to that in 2005?
Offer a very short reply. 0.99. What is the ratio of the Value added (% of GDP) of Kazakhstan in 2002 to that in 2005?
Provide a succinct answer. 0.96. What is the ratio of the Value added (% of GDP) in Fragile and conflict affected situations in 2002 to that in 2006?
Give a very brief answer. 0.87. What is the ratio of the Value added (% of GDP) of Guatemala in 2002 to that in 2006?
Your answer should be very brief. 0.97. What is the ratio of the Value added (% of GDP) in Kazakhstan in 2002 to that in 2006?
Give a very brief answer. 0.92. What is the ratio of the Value added (% of GDP) of Fragile and conflict affected situations in 2002 to that in 2007?
Give a very brief answer. 0.9. What is the ratio of the Value added (% of GDP) in Burkina Faso in 2002 to that in 2007?
Make the answer very short. 0.92. What is the ratio of the Value added (% of GDP) in Guatemala in 2002 to that in 2007?
Your answer should be compact. 0.98. What is the ratio of the Value added (% of GDP) in Kazakhstan in 2002 to that in 2007?
Your answer should be very brief. 0.95. What is the ratio of the Value added (% of GDP) of Burkina Faso in 2003 to that in 2004?
Make the answer very short. 1. What is the ratio of the Value added (% of GDP) in Guatemala in 2003 to that in 2004?
Offer a very short reply. 0.98. What is the ratio of the Value added (% of GDP) in Kazakhstan in 2003 to that in 2004?
Make the answer very short. 1. What is the ratio of the Value added (% of GDP) in Fragile and conflict affected situations in 2003 to that in 2005?
Your response must be concise. 0.92. What is the ratio of the Value added (% of GDP) of Burkina Faso in 2003 to that in 2005?
Your response must be concise. 1.18. What is the ratio of the Value added (% of GDP) of Guatemala in 2003 to that in 2005?
Keep it short and to the point. 1. What is the ratio of the Value added (% of GDP) of Kazakhstan in 2003 to that in 2005?
Keep it short and to the point. 0.94. What is the ratio of the Value added (% of GDP) of Fragile and conflict affected situations in 2003 to that in 2006?
Your answer should be very brief. 0.92. What is the ratio of the Value added (% of GDP) in Burkina Faso in 2003 to that in 2006?
Offer a terse response. 1.2. What is the ratio of the Value added (% of GDP) in Guatemala in 2003 to that in 2006?
Your answer should be very brief. 0.97. What is the ratio of the Value added (% of GDP) of Kazakhstan in 2003 to that in 2006?
Ensure brevity in your answer.  0.89. What is the ratio of the Value added (% of GDP) of Fragile and conflict affected situations in 2003 to that in 2007?
Your answer should be very brief. 0.95. What is the ratio of the Value added (% of GDP) of Burkina Faso in 2003 to that in 2007?
Provide a short and direct response. 1.12. What is the ratio of the Value added (% of GDP) of Guatemala in 2003 to that in 2007?
Offer a very short reply. 0.99. What is the ratio of the Value added (% of GDP) of Kazakhstan in 2003 to that in 2007?
Offer a terse response. 0.93. What is the ratio of the Value added (% of GDP) in Fragile and conflict affected situations in 2004 to that in 2005?
Your response must be concise. 0.93. What is the ratio of the Value added (% of GDP) in Burkina Faso in 2004 to that in 2005?
Make the answer very short. 1.18. What is the ratio of the Value added (% of GDP) of Guatemala in 2004 to that in 2005?
Provide a short and direct response. 1.02. What is the ratio of the Value added (% of GDP) in Kazakhstan in 2004 to that in 2005?
Offer a very short reply. 0.94. What is the ratio of the Value added (% of GDP) of Fragile and conflict affected situations in 2004 to that in 2006?
Offer a terse response. 0.92. What is the ratio of the Value added (% of GDP) of Burkina Faso in 2004 to that in 2006?
Keep it short and to the point. 1.2. What is the ratio of the Value added (% of GDP) of Kazakhstan in 2004 to that in 2006?
Give a very brief answer. 0.89. What is the ratio of the Value added (% of GDP) in Fragile and conflict affected situations in 2004 to that in 2007?
Your answer should be very brief. 0.96. What is the ratio of the Value added (% of GDP) of Burkina Faso in 2004 to that in 2007?
Your response must be concise. 1.12. What is the ratio of the Value added (% of GDP) in Kazakhstan in 2004 to that in 2007?
Ensure brevity in your answer.  0.93. What is the ratio of the Value added (% of GDP) in Fragile and conflict affected situations in 2005 to that in 2006?
Your answer should be compact. 0.99. What is the ratio of the Value added (% of GDP) in Burkina Faso in 2005 to that in 2006?
Provide a short and direct response. 1.02. What is the ratio of the Value added (% of GDP) in Guatemala in 2005 to that in 2006?
Give a very brief answer. 0.97. What is the ratio of the Value added (% of GDP) in Kazakhstan in 2005 to that in 2006?
Provide a succinct answer. 0.95. What is the ratio of the Value added (% of GDP) in Fragile and conflict affected situations in 2005 to that in 2007?
Offer a terse response. 1.03. What is the ratio of the Value added (% of GDP) of Burkina Faso in 2005 to that in 2007?
Your response must be concise. 0.95. What is the ratio of the Value added (% of GDP) of Guatemala in 2005 to that in 2007?
Make the answer very short. 0.99. What is the ratio of the Value added (% of GDP) in Kazakhstan in 2005 to that in 2007?
Ensure brevity in your answer.  0.99. What is the ratio of the Value added (% of GDP) in Fragile and conflict affected situations in 2006 to that in 2007?
Your response must be concise. 1.04. What is the ratio of the Value added (% of GDP) in Burkina Faso in 2006 to that in 2007?
Give a very brief answer. 0.93. What is the ratio of the Value added (% of GDP) of Guatemala in 2006 to that in 2007?
Offer a very short reply. 1.01. What is the ratio of the Value added (% of GDP) of Kazakhstan in 2006 to that in 2007?
Make the answer very short. 1.04. What is the difference between the highest and the second highest Value added (% of GDP) of Fragile and conflict affected situations?
Keep it short and to the point. 0.33. What is the difference between the highest and the second highest Value added (% of GDP) in Burkina Faso?
Offer a terse response. 0.01. What is the difference between the highest and the second highest Value added (% of GDP) of Guatemala?
Your response must be concise. 0.3. What is the difference between the highest and the second highest Value added (% of GDP) in Kazakhstan?
Your response must be concise. 1.46. What is the difference between the highest and the lowest Value added (% of GDP) of Fragile and conflict affected situations?
Give a very brief answer. 4.7. What is the difference between the highest and the lowest Value added (% of GDP) in Burkina Faso?
Your answer should be very brief. 3.66. What is the difference between the highest and the lowest Value added (% of GDP) in Guatemala?
Your answer should be compact. 0.98. What is the difference between the highest and the lowest Value added (% of GDP) of Kazakhstan?
Offer a very short reply. 4.49. 